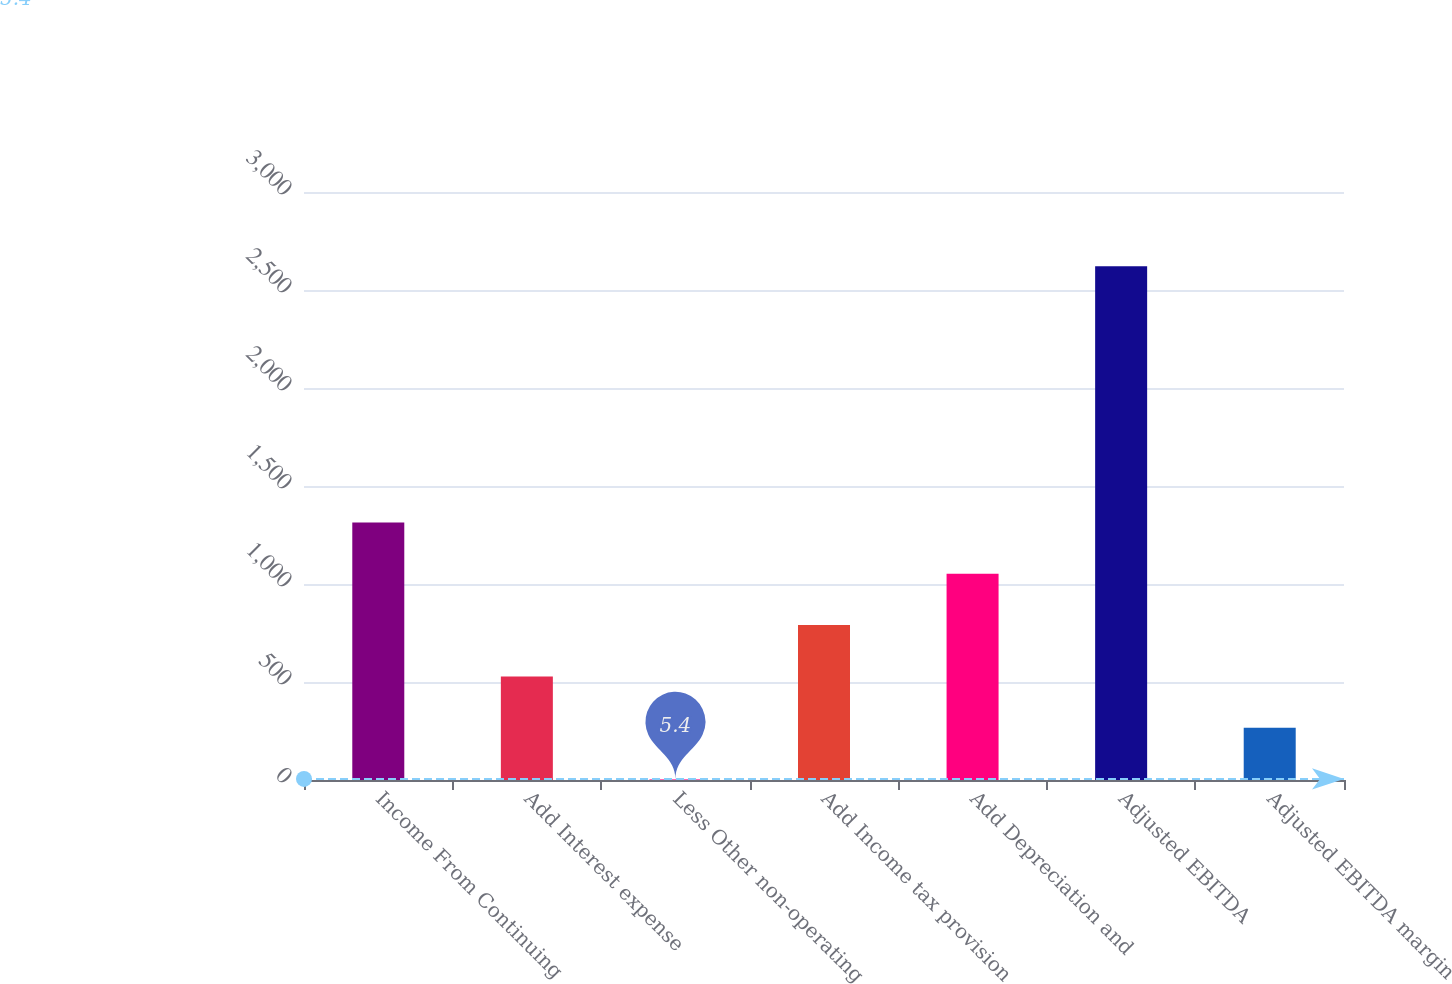Convert chart to OTSL. <chart><loc_0><loc_0><loc_500><loc_500><bar_chart><fcel>Income From Continuing<fcel>Add Interest expense<fcel>Less Other non-operating<fcel>Add Income tax provision<fcel>Add Depreciation and<fcel>Adjusted EBITDA<fcel>Adjusted EBITDA margin<nl><fcel>1313.6<fcel>528.68<fcel>5.4<fcel>790.32<fcel>1051.96<fcel>2621.8<fcel>267.04<nl></chart> 